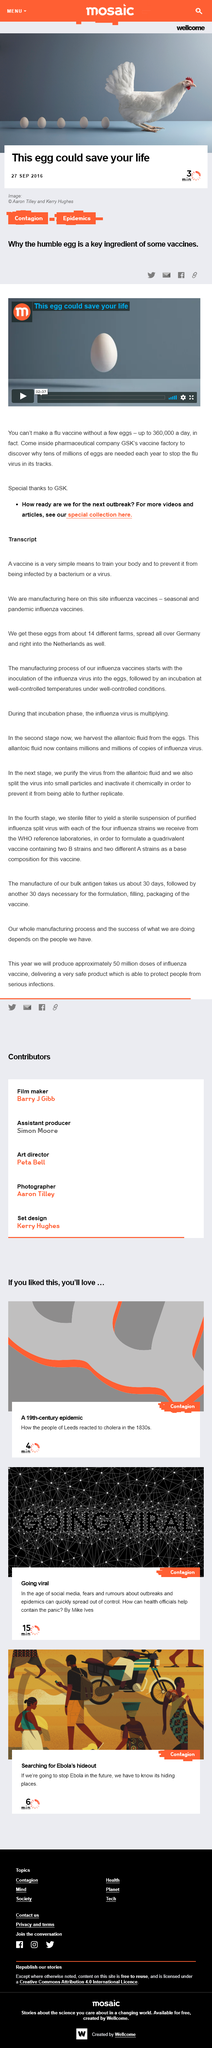Give some essential details in this illustration. A vaccine is a simple and effective means to train the body and prevent it from being affected by bacteria or viruses. The influenza virus in the eggs used for vaccine production is obtained from approximately 14 different farms. Eggs play a critical role in the development of the flu vaccine, and they can potentially save lives by being included in the vaccine. Yes, eggs are required for the production of the flu vaccine. Up to 360,000 eggs per day are used to produce flu vaccines. 